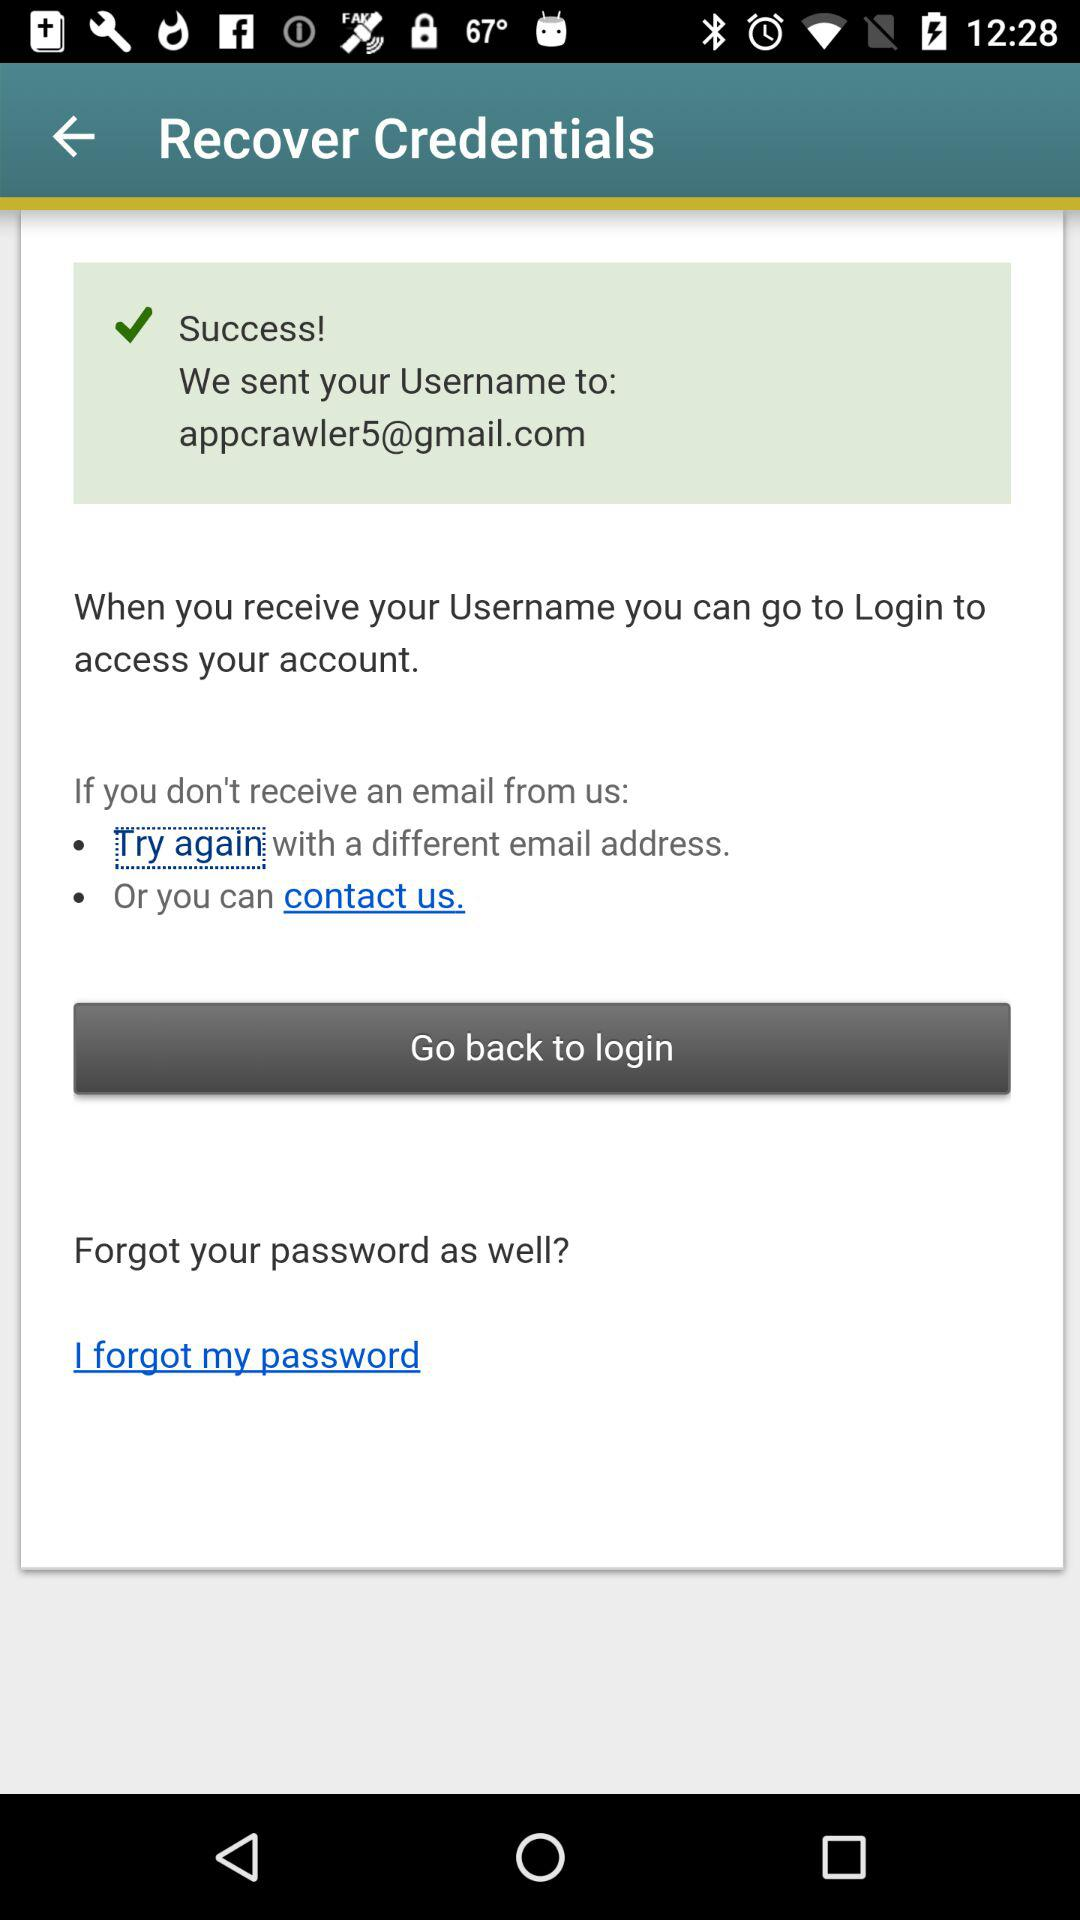Which contact options are available for the user?
When the provided information is insufficient, respond with <no answer>. <no answer> 